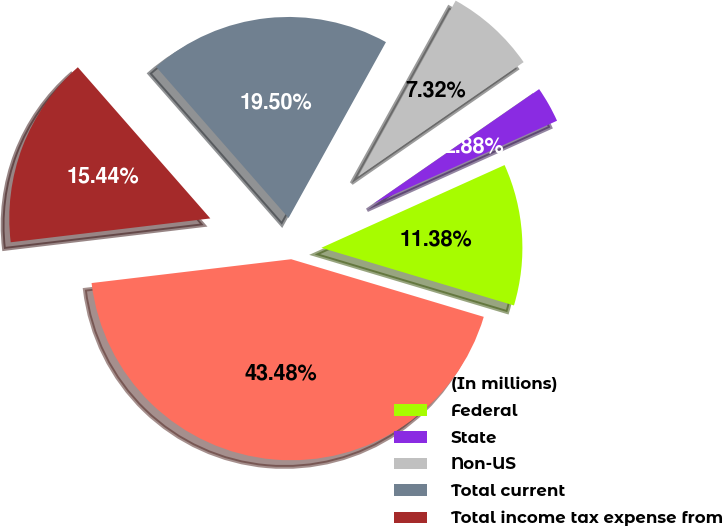Convert chart. <chart><loc_0><loc_0><loc_500><loc_500><pie_chart><fcel>(In millions)<fcel>Federal<fcel>State<fcel>Non-US<fcel>Total current<fcel>Total income tax expense from<nl><fcel>43.48%<fcel>11.38%<fcel>2.88%<fcel>7.32%<fcel>19.5%<fcel>15.44%<nl></chart> 